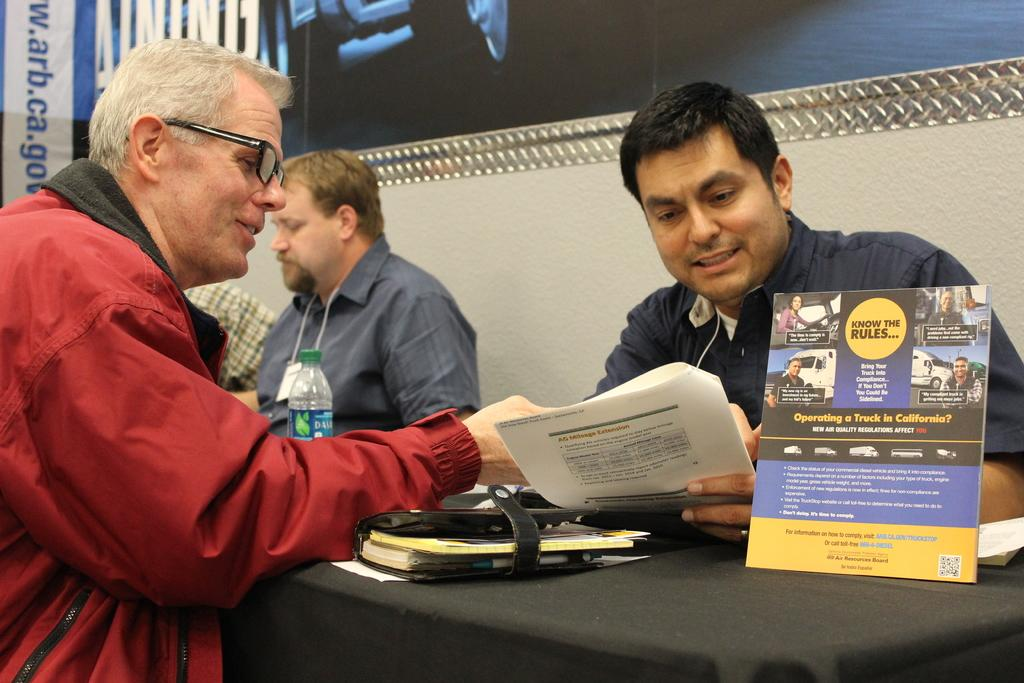What are the people in the image doing? The people in the image are sitting. What is the man holding in the image? The man is holding papers in the image. What can be seen on the table in the image? There are objects on a table in the image. What is present on the wall in the background of the image? There is a banner in the background of the image. What type of canvas is being used to stitch the air in the image? There is no canvas, stitching, or air present in the image. 